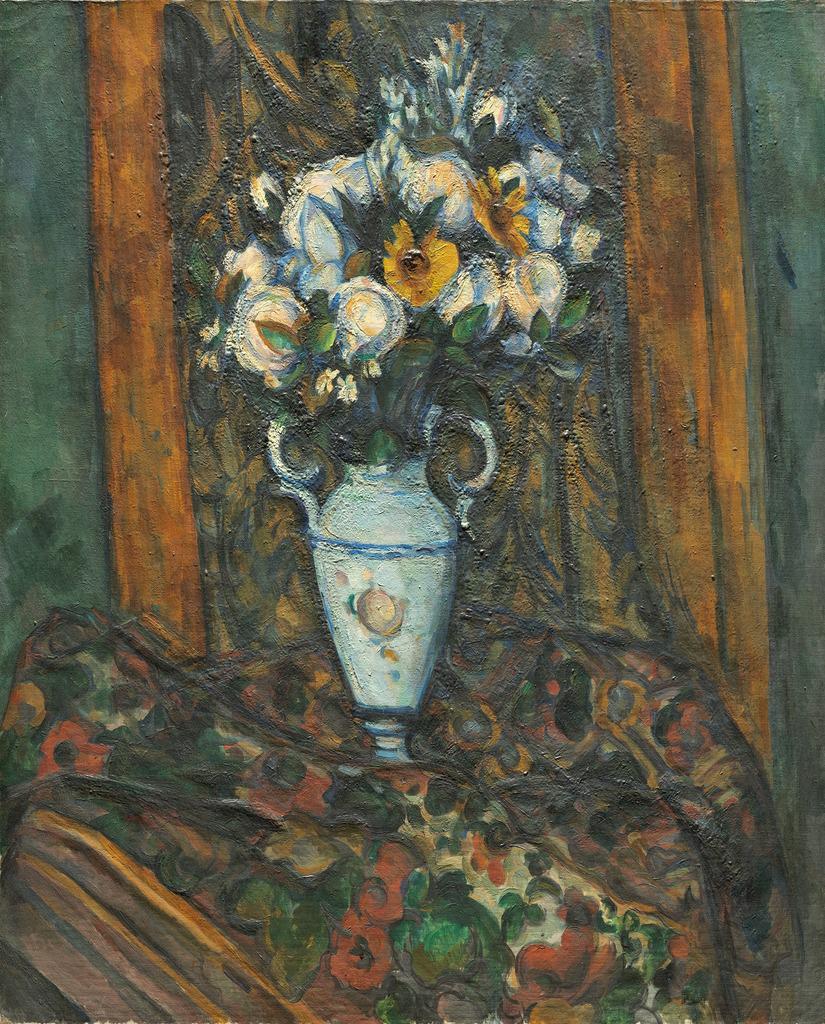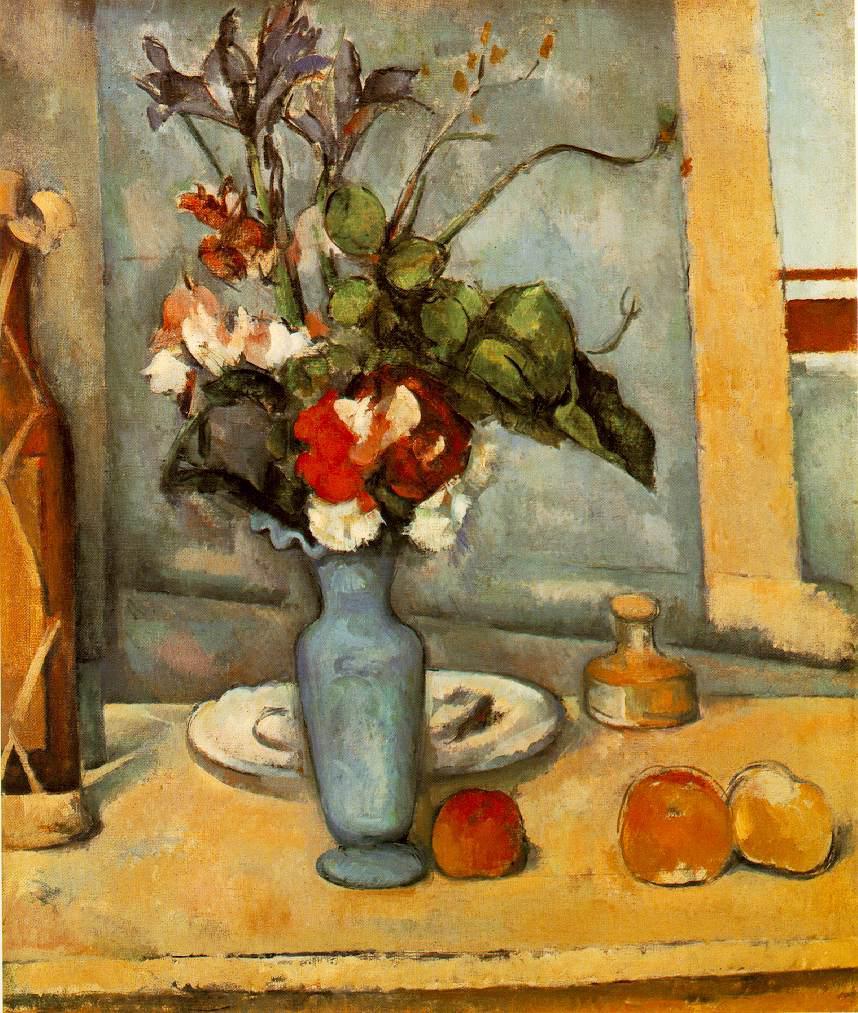The first image is the image on the left, the second image is the image on the right. Analyze the images presented: Is the assertion "In one image there is a vase of flowers next to several pieces of fruit on a tabletop." valid? Answer yes or no. Yes. The first image is the image on the left, the second image is the image on the right. For the images displayed, is the sentence "One of the pictures shows a vase on a table with at least three round fruit also displayed on the table." factually correct? Answer yes or no. Yes. 